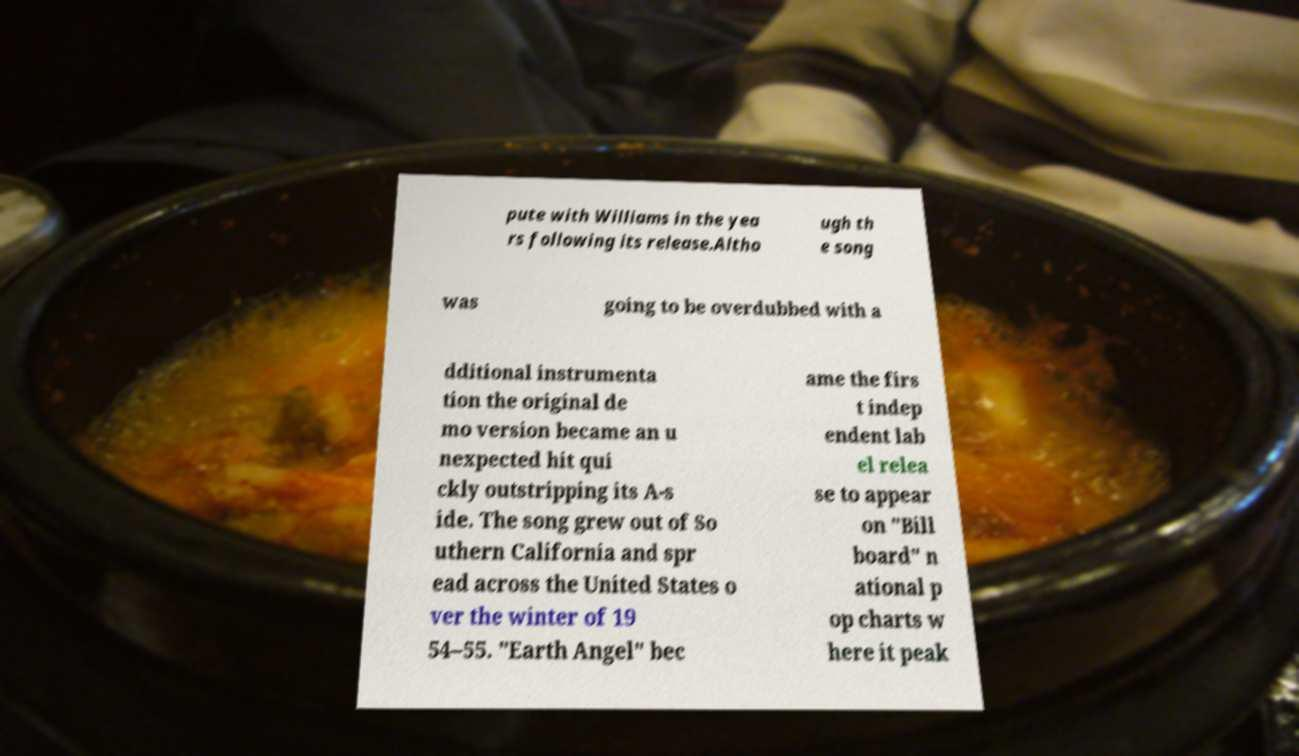For documentation purposes, I need the text within this image transcribed. Could you provide that? pute with Williams in the yea rs following its release.Altho ugh th e song was going to be overdubbed with a dditional instrumenta tion the original de mo version became an u nexpected hit qui ckly outstripping its A-s ide. The song grew out of So uthern California and spr ead across the United States o ver the winter of 19 54–55. "Earth Angel" bec ame the firs t indep endent lab el relea se to appear on "Bill board" n ational p op charts w here it peak 